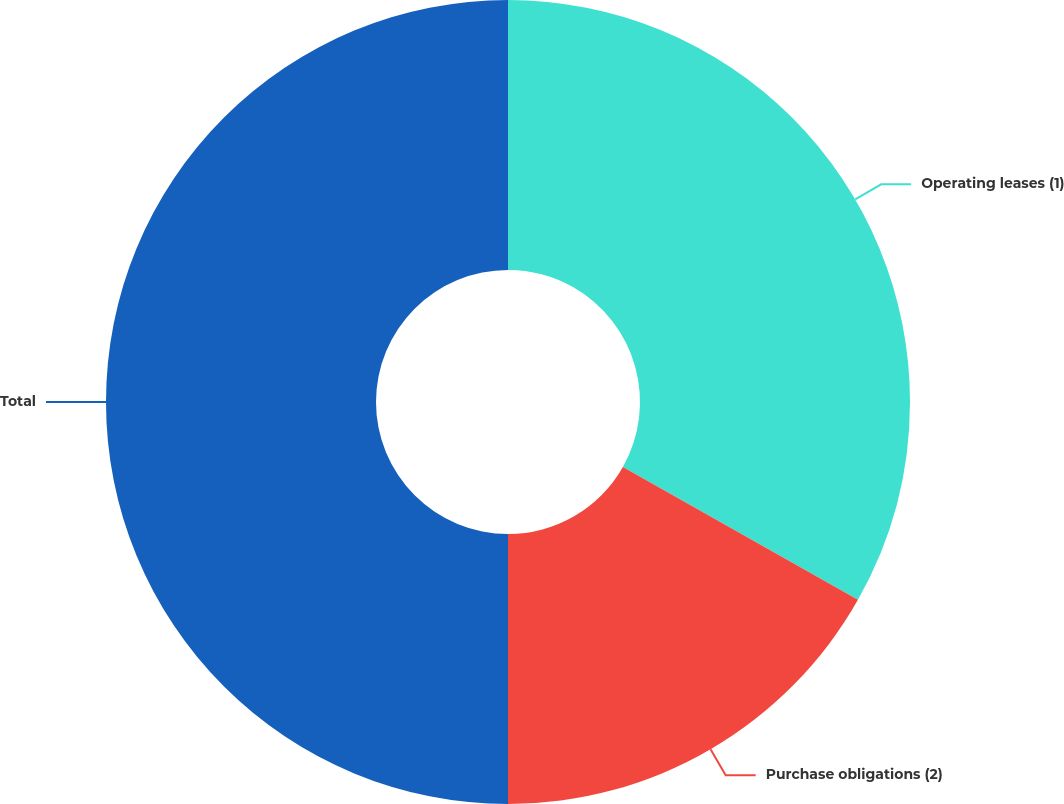Convert chart to OTSL. <chart><loc_0><loc_0><loc_500><loc_500><pie_chart><fcel>Operating leases (1)<fcel>Purchase obligations (2)<fcel>Total<nl><fcel>33.19%<fcel>16.81%<fcel>50.0%<nl></chart> 